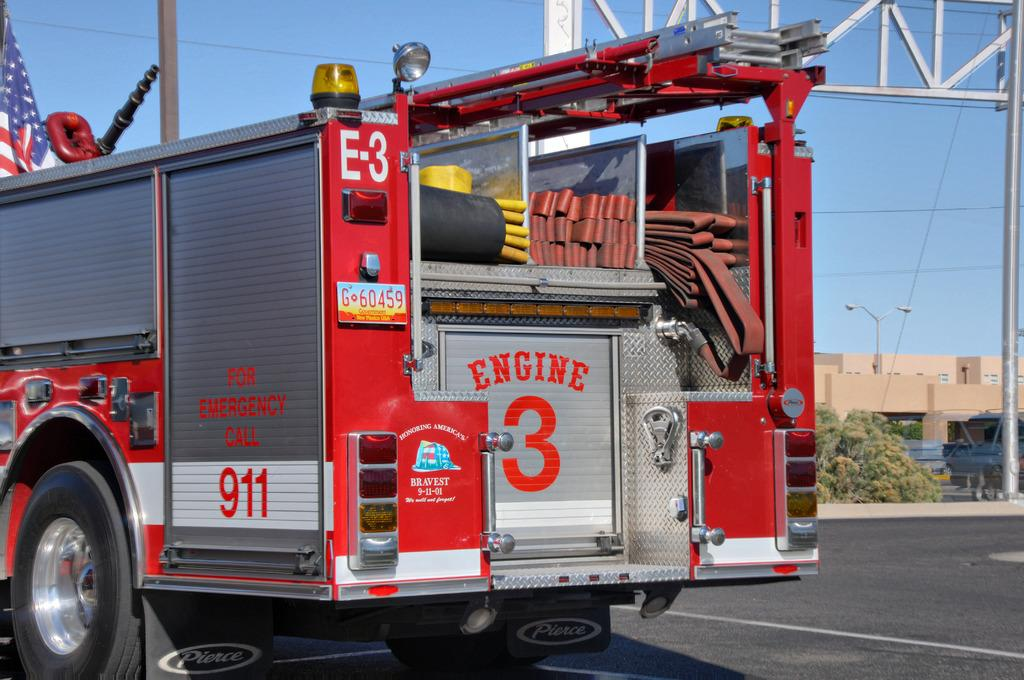What type of vehicle is in the image? There is a red fire extinguisher van in the image. Where is the van located? The van is on the road. What can be seen in the background of the image? There are brown small houses in the background. Can you describe a specific feature on the front right side of the image? There is a silver metal frame on the front right side of the image. What advice does the uncle give to the partner in the image? There is no uncle or partner present in the image, so it is not possible to answer that question. 